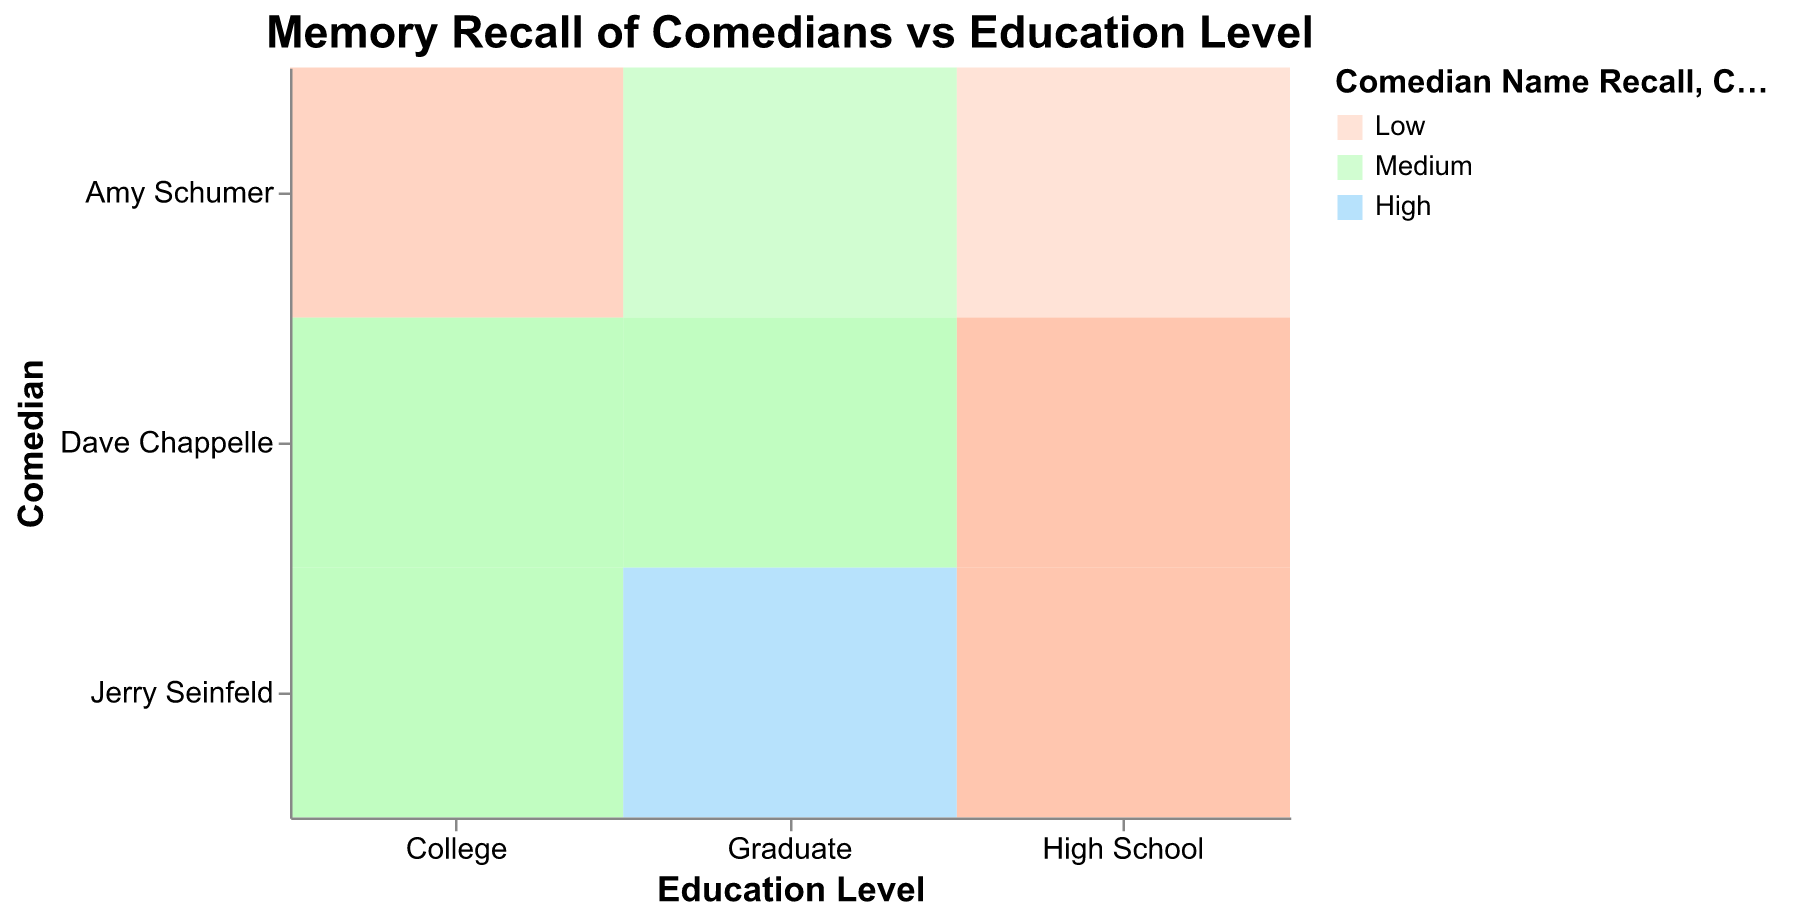How many education levels are shown in the figure? The figure has three education levels represented on the x-axis: "High School," "College," and "Graduate."
Answer: Three Which comedian has the highest name recall for each education level? We need to look at the color coding for "High" on the legend: Jerry Seinfeld (High School: Low, College: Medium, Graduate: High), Dave Chappelle (High School: Low, College: Medium, Graduate: Medium), Amy Schumer (always Low or Medium).
Answer: Jerry Seinfeld for Graduate What is the variation in comedian name recall for Amy Schumer across education levels? Amy Schumer's name recall varies as follows: High School (Low), College (Low), and Graduate (Medium). We need to check the color shades specified in the legend for confirmation.
Answer: Low, Low, Medium For which comedian and education level is the catchphrase recall low? We can identify low opacity (faint color) for catchphrase recall from the legend. Only Amy Schumer in High School shows "Low" recall for catchphrases.
Answer: Amy Schumer at High School Which group shows a combination of high name recall and high catchphrase recall for Jerry Seinfeld? We check the color for high name recall and opacity for high catchphrase recall. Only Jerry Seinfeld in Graduate shows this combination.
Answer: Jerry Seinfeld at Graduate Is there any education level where all comedians have the same catchphrase recall? We look at the consistent opacity level across all comedians. In High School, Dave Chappelle and Jerry Seinfeld have high recall while Amy Schumer has low recall; in College, Jerry Seinfeld and Dave Chappelle have high recall while Amy Schumer has medium recall; in Graduate, all held high till they have medium recalls for Amy Schumer and Dave Chappelle.
Answer: None Which comedian has the lowest name recall among those with a college education? We check the shading for the lowest recall level within College, and we find Amy Schumer with low recall.
Answer: Amy Schumer Between High School and College educations, how does the comedian name recall differ for Dave Chappelle? In High School, the recall is low (lighter shade), whereas in College it's medium (darker shade).
Answer: Low in High School, Medium in College Is catchphrase recall higher at any education level for Amy Schumer as compared to Jerry Seinfeld? We compare opacity levels for each education combination. Jerry Seinfeld has consistently high catchphrase recall across all education levels, while Amy Schumer never reaches high.
Answer: No How does the comedian name recall differ from High School to Graduate level for Dave Chappelle? We compare the shading of segments corresponding to Dave Chappelle in both education levels: Low (High School) and Medium (Graduate).
Answer: Low to Medium 